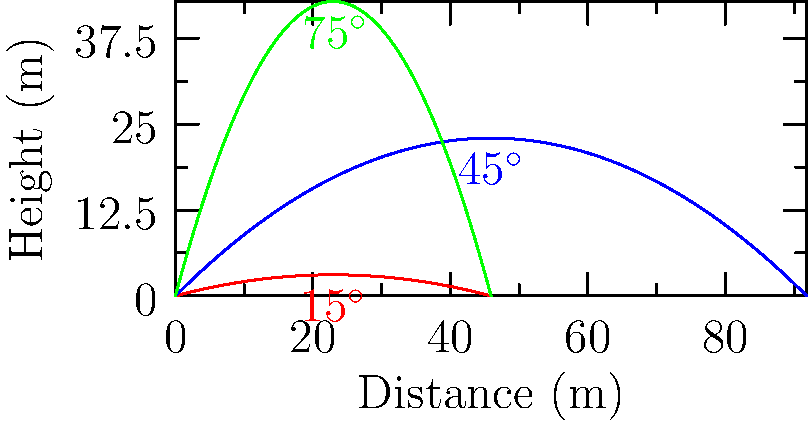As a leader fostering a positive work culture, you organize a team-building activity involving projectile motion demonstrations. Three seasoned employees launch projectiles at angles of 15°, 45°, and 75° with an initial velocity of 30 m/s. Which launch angle results in the greatest horizontal distance traveled by the projectile? To determine which launch angle results in the greatest horizontal distance, we'll follow these steps:

1) The horizontal distance traveled by a projectile is given by the formula:
   $$R = \frac{v_0^2 \sin(2\theta)}{g}$$
   where $R$ is the range, $v_0$ is the initial velocity, $\theta$ is the launch angle, and $g$ is the acceleration due to gravity.

2) We're given:
   $v_0 = 30$ m/s
   $g = 9.8$ m/s²
   $\theta = 15°, 45°, 75°$

3) Let's calculate the range for each angle:

   For 15°:
   $$R = \frac{30^2 \sin(2(15°))}{9.8} = \frac{900 \sin(30°)}{9.8} = \frac{900 (0.5)}{9.8} = 45.92 \text{ m}$$

   For 45°:
   $$R = \frac{30^2 \sin(2(45°))}{9.8} = \frac{900 \sin(90°)}{9.8} = \frac{900 (1)}{9.8} = 91.84 \text{ m}$$

   For 75°:
   $$R = \frac{30^2 \sin(2(75°))}{9.8} = \frac{900 \sin(150°)}{9.8} = \frac{900 (0.5)}{9.8} = 45.92 \text{ m}$$

4) Comparing the results, we see that 45° gives the greatest range.

This result aligns with the theoretical maximum range occurring at a 45° launch angle (in the absence of air resistance).
Answer: 45° 